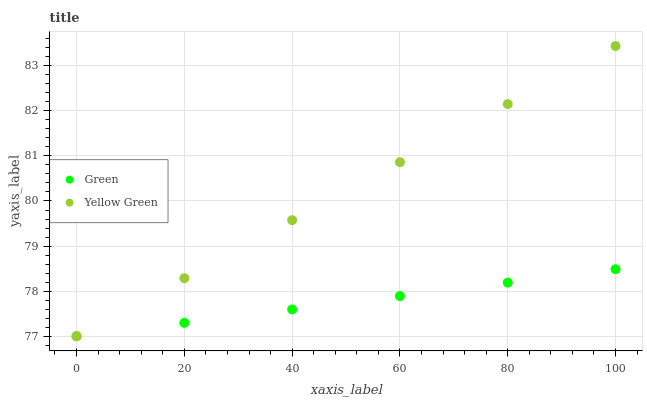Does Green have the minimum area under the curve?
Answer yes or no. Yes. Does Yellow Green have the maximum area under the curve?
Answer yes or no. Yes. Does Yellow Green have the minimum area under the curve?
Answer yes or no. No. Is Yellow Green the smoothest?
Answer yes or no. Yes. Is Green the roughest?
Answer yes or no. Yes. Is Yellow Green the roughest?
Answer yes or no. No. Does Green have the lowest value?
Answer yes or no. Yes. Does Yellow Green have the highest value?
Answer yes or no. Yes. Does Green intersect Yellow Green?
Answer yes or no. Yes. Is Green less than Yellow Green?
Answer yes or no. No. Is Green greater than Yellow Green?
Answer yes or no. No. 